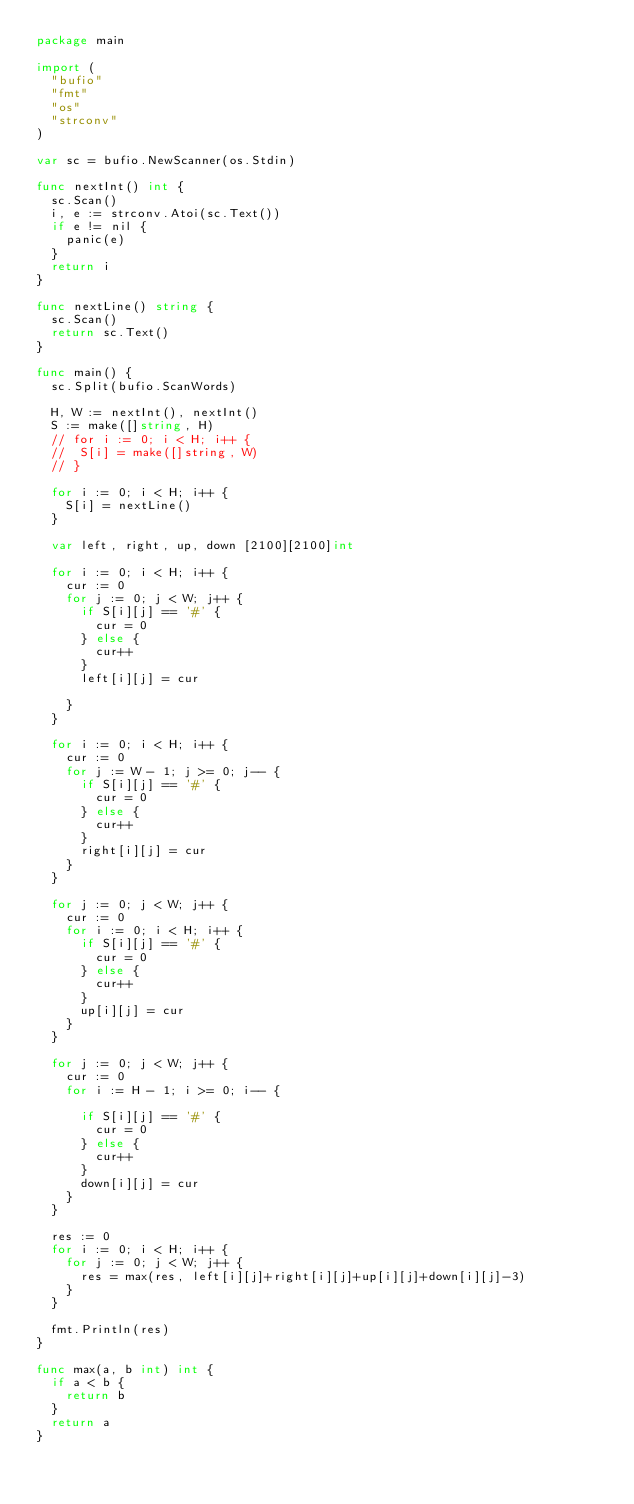Convert code to text. <code><loc_0><loc_0><loc_500><loc_500><_Go_>package main

import (
	"bufio"
	"fmt"
	"os"
	"strconv"
)

var sc = bufio.NewScanner(os.Stdin)

func nextInt() int {
	sc.Scan()
	i, e := strconv.Atoi(sc.Text())
	if e != nil {
		panic(e)
	}
	return i
}

func nextLine() string {
	sc.Scan()
	return sc.Text()
}

func main() {
	sc.Split(bufio.ScanWords)

	H, W := nextInt(), nextInt()
	S := make([]string, H)
	// for i := 0; i < H; i++ {
	// 	S[i] = make([]string, W)
	// }

	for i := 0; i < H; i++ {
		S[i] = nextLine()
	}

	var left, right, up, down [2100][2100]int

	for i := 0; i < H; i++ {
		cur := 0
		for j := 0; j < W; j++ {
			if S[i][j] == '#' {
				cur = 0
			} else {
				cur++
			}
			left[i][j] = cur

		}
	}

	for i := 0; i < H; i++ {
		cur := 0
		for j := W - 1; j >= 0; j-- {
			if S[i][j] == '#' {
				cur = 0
			} else {
				cur++
			}
			right[i][j] = cur
		}
	}

	for j := 0; j < W; j++ {
		cur := 0
		for i := 0; i < H; i++ {
			if S[i][j] == '#' {
				cur = 0
			} else {
				cur++
			}
			up[i][j] = cur
		}
	}

	for j := 0; j < W; j++ {
		cur := 0
		for i := H - 1; i >= 0; i-- {

			if S[i][j] == '#' {
				cur = 0
			} else {
				cur++
			}
			down[i][j] = cur
		}
	}

	res := 0
	for i := 0; i < H; i++ {
		for j := 0; j < W; j++ {
			res = max(res, left[i][j]+right[i][j]+up[i][j]+down[i][j]-3)
		}
	}

	fmt.Println(res)
}

func max(a, b int) int {
	if a < b {
		return b
	}
	return a
}
</code> 